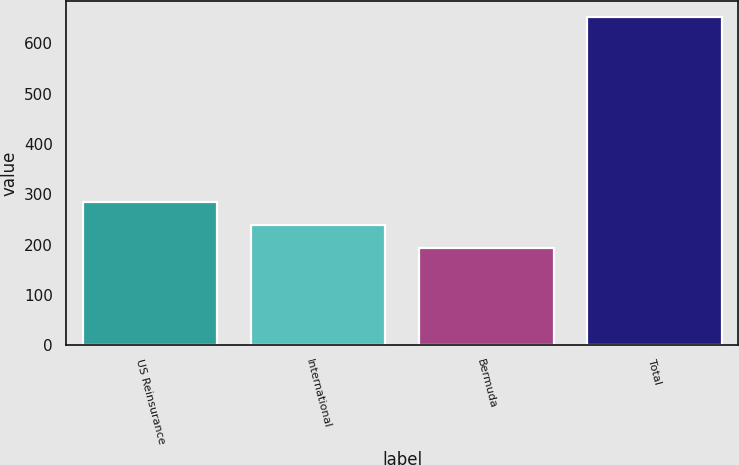Convert chart. <chart><loc_0><loc_0><loc_500><loc_500><bar_chart><fcel>US Reinsurance<fcel>International<fcel>Bermuda<fcel>Total<nl><fcel>285.52<fcel>239.76<fcel>194<fcel>651.6<nl></chart> 